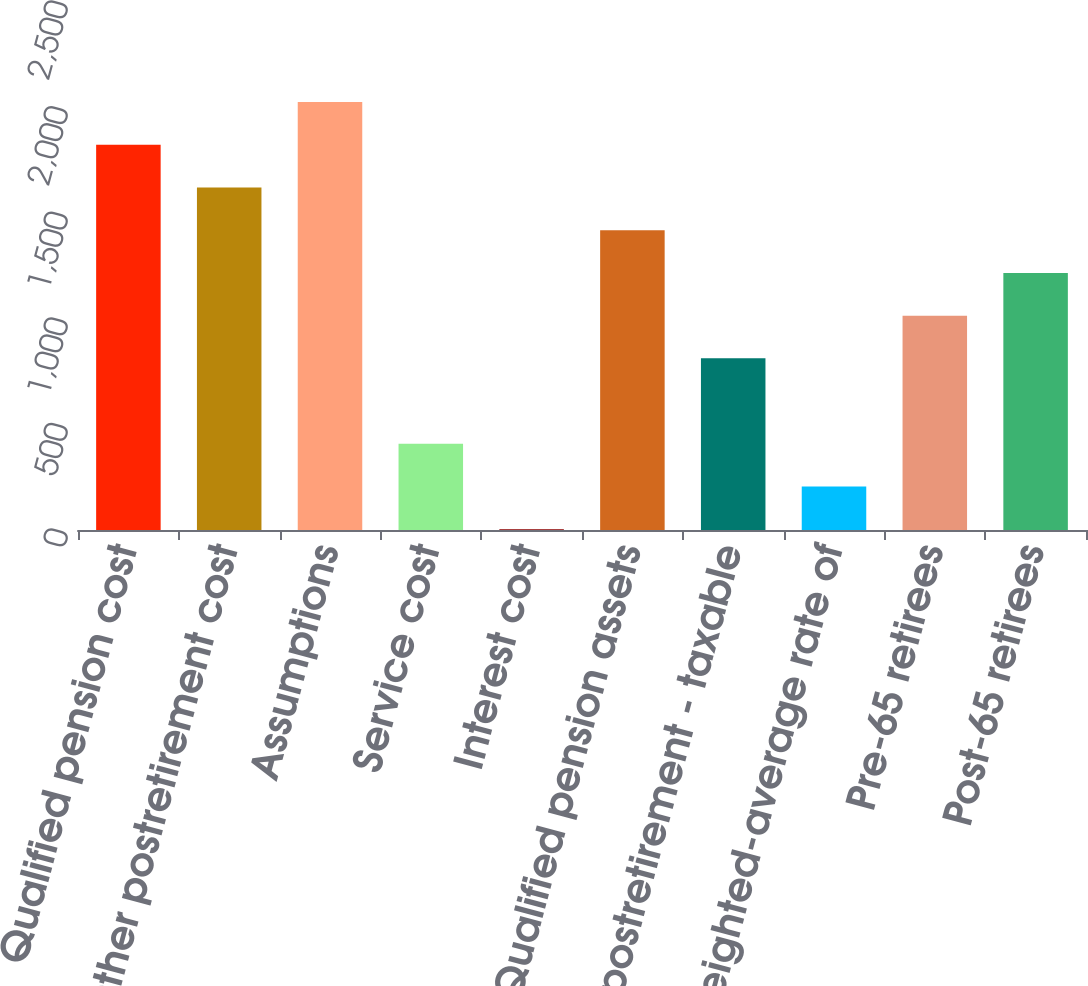Convert chart to OTSL. <chart><loc_0><loc_0><loc_500><loc_500><bar_chart><fcel>Qualified pension cost<fcel>Other postretirement cost<fcel>Assumptions<fcel>Service cost<fcel>Interest cost<fcel>Qualified pension assets<fcel>Other postretirement - taxable<fcel>Weighted-average rate of<fcel>Pre-65 retirees<fcel>Post-65 retirees<nl><fcel>1823.8<fcel>1621.57<fcel>2026.03<fcel>408.19<fcel>3.73<fcel>1419.34<fcel>812.65<fcel>205.96<fcel>1014.88<fcel>1217.11<nl></chart> 